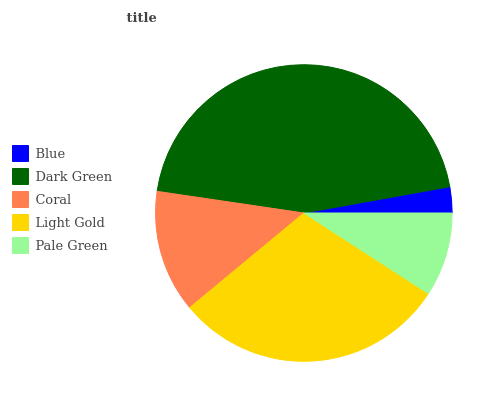Is Blue the minimum?
Answer yes or no. Yes. Is Dark Green the maximum?
Answer yes or no. Yes. Is Coral the minimum?
Answer yes or no. No. Is Coral the maximum?
Answer yes or no. No. Is Dark Green greater than Coral?
Answer yes or no. Yes. Is Coral less than Dark Green?
Answer yes or no. Yes. Is Coral greater than Dark Green?
Answer yes or no. No. Is Dark Green less than Coral?
Answer yes or no. No. Is Coral the high median?
Answer yes or no. Yes. Is Coral the low median?
Answer yes or no. Yes. Is Pale Green the high median?
Answer yes or no. No. Is Light Gold the low median?
Answer yes or no. No. 